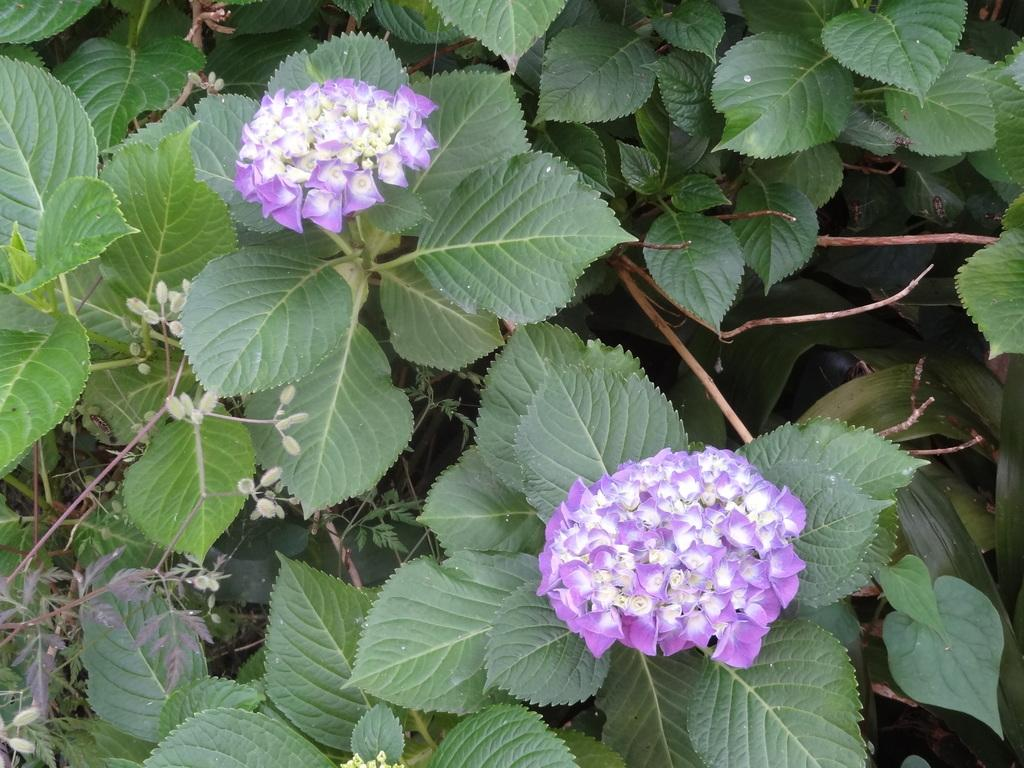What type of plants can be seen in the picture? There are flower plants in the picture. What is the color of the flowers on these plants? The flowers are purple in color. What type of collar is visible on the fire in the image? There is no collar or fire present in the image; it features flower plants with purple flowers. 